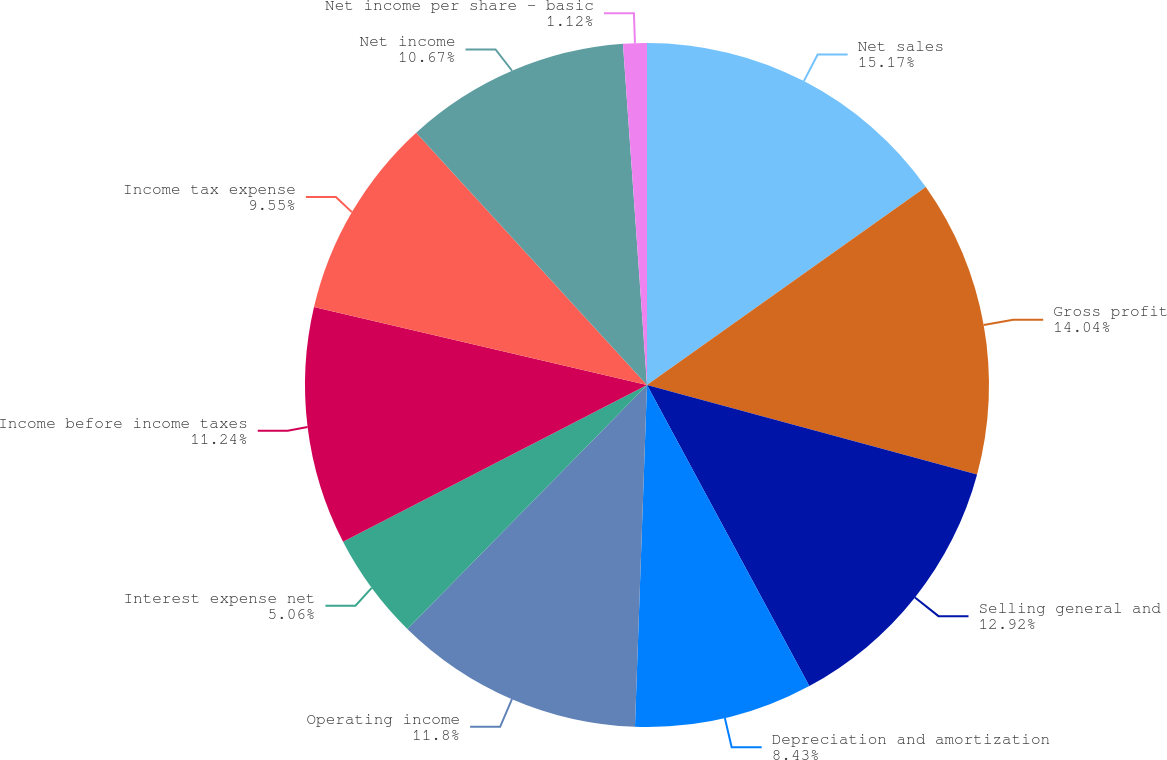Convert chart. <chart><loc_0><loc_0><loc_500><loc_500><pie_chart><fcel>Net sales<fcel>Gross profit<fcel>Selling general and<fcel>Depreciation and amortization<fcel>Operating income<fcel>Interest expense net<fcel>Income before income taxes<fcel>Income tax expense<fcel>Net income<fcel>Net income per share - basic<nl><fcel>15.17%<fcel>14.04%<fcel>12.92%<fcel>8.43%<fcel>11.8%<fcel>5.06%<fcel>11.24%<fcel>9.55%<fcel>10.67%<fcel>1.12%<nl></chart> 